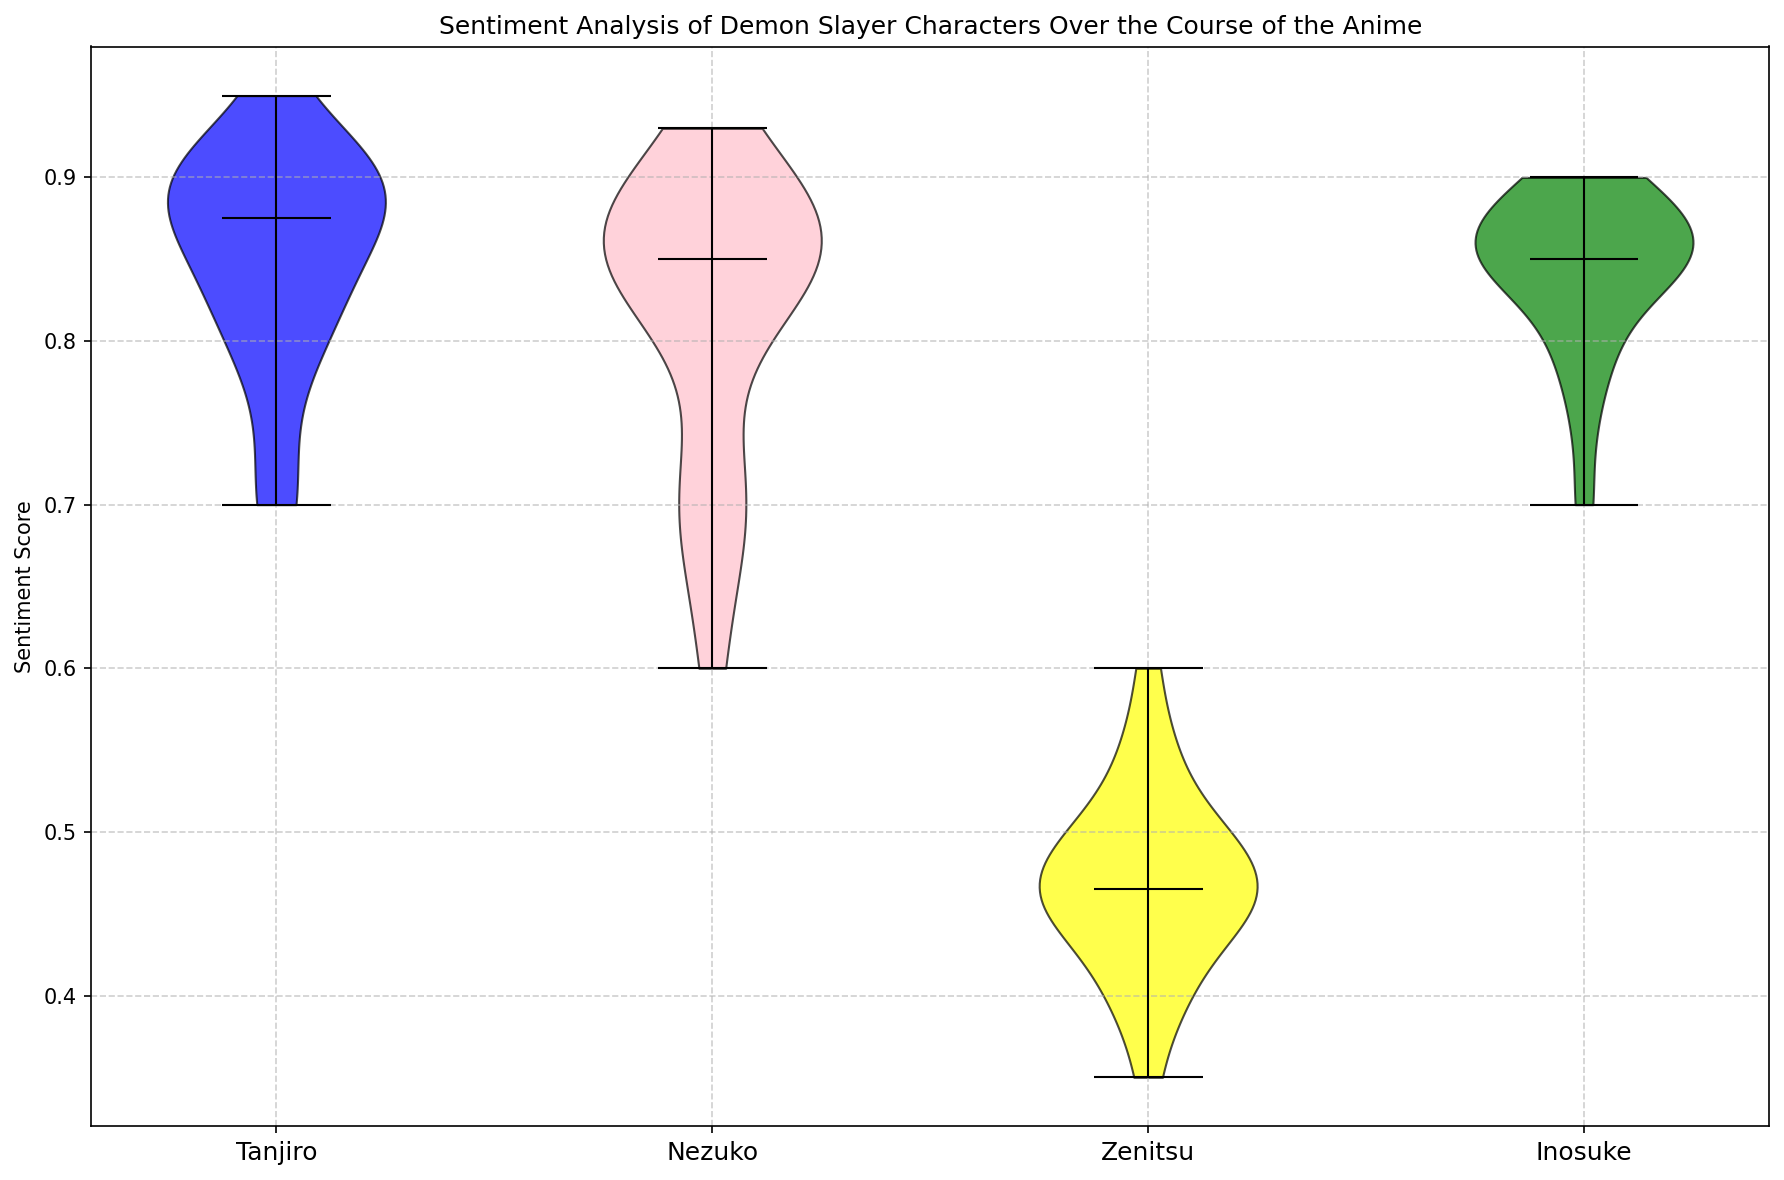What is the median sentiment score for Tanjiro? Locate the median marker (typically a line or dot) within the violin representing Tanjiro, and read its value on the y-axis.
Answer: 0.875 Which character has the highest median sentiment score? Compare the median markers in each character's violin plot. Identify the character whose median marker is at the highest position on the y-axis.
Answer: Nezuko Are there any characters with overlapping sentiment score distributions? Observe the shapes and extents of the violins. Check if any violins overlap along the y-axis.
Answer: Yes, Inosuke and Tanjiro have overlapping distributions Whose sentiment score distribution shows the widest spread? Visually inspect the violins' width on the y-axis and determine which one spans the largest range.
Answer: Zenitsu Between Tanjiro and Zenitsu, whose sentiment score is more consistent? Examine the range of each violin. A narrower range indicates more consistency. Tanjiro's violin is narrower compared to Zenitsu's.
Answer: Tanjiro Which character has a mid-range sentiment score that is least skewed? Look for the character whose median line is centrally located within the violin, showing symmetry around the median.
Answer: Nezuko Is the sentiment score for Inosuke generally higher or lower compared to Zenitsu? Compare the overall positions of the violins for Inosuke and Zenitsu. Inosuke's sentiment scores are generally higher.
Answer: Higher Does Nezuko's sentiment score distribution have a higher peak compared to Tanjiro's? Check the density and height of the violin's central part to see if Nezuko's distribution peaks higher than Tanjiro's.
Answer: Yes How does the sentiment score variability of Inosuke compare to that of Nezuko? Compare the width of Inosuke's and Nezuko's violins. The wider the violin, the higher the variability. Inosuke's violin is slightly wider.
Answer: Inosuke is more variable Which characters have sentiment scores predominantly above 0.5? Observe the violins of each character and determine if the majority of their distribution lies above the 0.5 mark. Tanjiro, Nezuko, and Inosuke have distributions predominantly above 0.5.
Answer: Tanjiro, Nezuko, Inosuke 